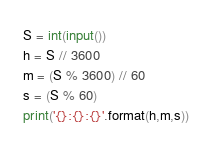Convert code to text. <code><loc_0><loc_0><loc_500><loc_500><_Python_>S = int(input())
h = S // 3600
m = (S % 3600) // 60
s = (S % 60)
print('{}:{}:{}'.format(h,m,s))</code> 